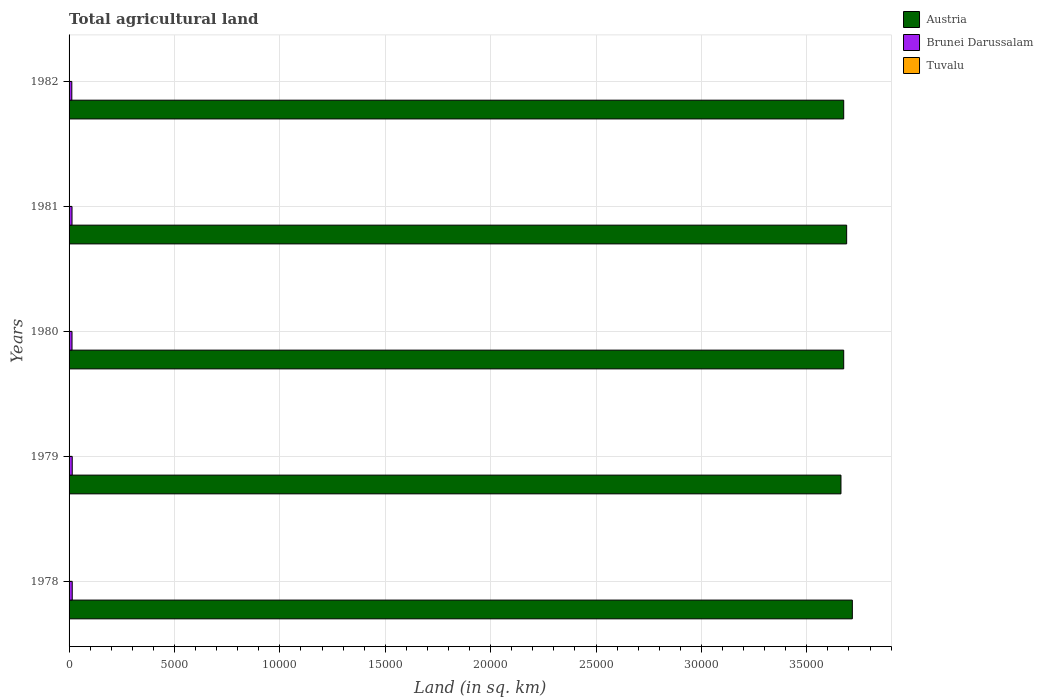How many different coloured bars are there?
Your answer should be very brief. 3. How many groups of bars are there?
Give a very brief answer. 5. Are the number of bars per tick equal to the number of legend labels?
Offer a terse response. Yes. Are the number of bars on each tick of the Y-axis equal?
Provide a short and direct response. Yes. How many bars are there on the 2nd tick from the top?
Make the answer very short. 3. What is the label of the 1st group of bars from the top?
Provide a short and direct response. 1982. What is the total agricultural land in Austria in 1978?
Your answer should be compact. 3.72e+04. Across all years, what is the maximum total agricultural land in Tuvalu?
Offer a terse response. 20. Across all years, what is the minimum total agricultural land in Tuvalu?
Offer a terse response. 20. In which year was the total agricultural land in Tuvalu maximum?
Ensure brevity in your answer.  1978. In which year was the total agricultural land in Brunei Darussalam minimum?
Provide a succinct answer. 1982. What is the total total agricultural land in Austria in the graph?
Ensure brevity in your answer.  1.84e+05. What is the difference between the total agricultural land in Tuvalu in 1981 and that in 1982?
Offer a very short reply. 0. What is the difference between the total agricultural land in Tuvalu in 1981 and the total agricultural land in Austria in 1978?
Offer a terse response. -3.71e+04. What is the average total agricultural land in Brunei Darussalam per year?
Keep it short and to the point. 142. In the year 1978, what is the difference between the total agricultural land in Brunei Darussalam and total agricultural land in Tuvalu?
Give a very brief answer. 130. In how many years, is the total agricultural land in Tuvalu greater than 3000 sq.km?
Offer a terse response. 0. What is the difference between the highest and the second highest total agricultural land in Brunei Darussalam?
Your answer should be compact. 0. What is the difference between the highest and the lowest total agricultural land in Austria?
Offer a terse response. 540. Is the sum of the total agricultural land in Brunei Darussalam in 1980 and 1981 greater than the maximum total agricultural land in Austria across all years?
Provide a short and direct response. No. What does the 1st bar from the top in 1981 represents?
Ensure brevity in your answer.  Tuvalu. What does the 2nd bar from the bottom in 1978 represents?
Your answer should be very brief. Brunei Darussalam. Are all the bars in the graph horizontal?
Provide a short and direct response. Yes. Are the values on the major ticks of X-axis written in scientific E-notation?
Give a very brief answer. No. Does the graph contain grids?
Offer a very short reply. Yes. Where does the legend appear in the graph?
Your answer should be compact. Top right. How many legend labels are there?
Your answer should be very brief. 3. How are the legend labels stacked?
Offer a very short reply. Vertical. What is the title of the graph?
Make the answer very short. Total agricultural land. What is the label or title of the X-axis?
Your response must be concise. Land (in sq. km). What is the Land (in sq. km) in Austria in 1978?
Ensure brevity in your answer.  3.72e+04. What is the Land (in sq. km) of Brunei Darussalam in 1978?
Offer a very short reply. 150. What is the Land (in sq. km) of Austria in 1979?
Provide a short and direct response. 3.66e+04. What is the Land (in sq. km) of Brunei Darussalam in 1979?
Your response must be concise. 150. What is the Land (in sq. km) in Tuvalu in 1979?
Your answer should be compact. 20. What is the Land (in sq. km) of Austria in 1980?
Your answer should be compact. 3.68e+04. What is the Land (in sq. km) in Brunei Darussalam in 1980?
Provide a short and direct response. 140. What is the Land (in sq. km) in Tuvalu in 1980?
Make the answer very short. 20. What is the Land (in sq. km) of Austria in 1981?
Keep it short and to the point. 3.69e+04. What is the Land (in sq. km) in Brunei Darussalam in 1981?
Provide a short and direct response. 140. What is the Land (in sq. km) of Austria in 1982?
Provide a succinct answer. 3.68e+04. What is the Land (in sq. km) in Brunei Darussalam in 1982?
Your response must be concise. 130. Across all years, what is the maximum Land (in sq. km) in Austria?
Make the answer very short. 3.72e+04. Across all years, what is the maximum Land (in sq. km) in Brunei Darussalam?
Provide a succinct answer. 150. Across all years, what is the maximum Land (in sq. km) of Tuvalu?
Provide a succinct answer. 20. Across all years, what is the minimum Land (in sq. km) in Austria?
Your answer should be compact. 3.66e+04. Across all years, what is the minimum Land (in sq. km) in Brunei Darussalam?
Ensure brevity in your answer.  130. What is the total Land (in sq. km) in Austria in the graph?
Your answer should be very brief. 1.84e+05. What is the total Land (in sq. km) in Brunei Darussalam in the graph?
Your response must be concise. 710. What is the difference between the Land (in sq. km) in Austria in 1978 and that in 1979?
Your response must be concise. 540. What is the difference between the Land (in sq. km) of Brunei Darussalam in 1978 and that in 1979?
Your answer should be compact. 0. What is the difference between the Land (in sq. km) in Tuvalu in 1978 and that in 1979?
Keep it short and to the point. 0. What is the difference between the Land (in sq. km) in Austria in 1978 and that in 1980?
Your answer should be compact. 410. What is the difference between the Land (in sq. km) in Austria in 1978 and that in 1981?
Offer a very short reply. 270. What is the difference between the Land (in sq. km) in Tuvalu in 1978 and that in 1981?
Your answer should be compact. 0. What is the difference between the Land (in sq. km) in Austria in 1978 and that in 1982?
Your response must be concise. 410. What is the difference between the Land (in sq. km) of Tuvalu in 1978 and that in 1982?
Offer a terse response. 0. What is the difference between the Land (in sq. km) in Austria in 1979 and that in 1980?
Make the answer very short. -130. What is the difference between the Land (in sq. km) in Brunei Darussalam in 1979 and that in 1980?
Keep it short and to the point. 10. What is the difference between the Land (in sq. km) in Tuvalu in 1979 and that in 1980?
Ensure brevity in your answer.  0. What is the difference between the Land (in sq. km) of Austria in 1979 and that in 1981?
Give a very brief answer. -270. What is the difference between the Land (in sq. km) in Tuvalu in 1979 and that in 1981?
Give a very brief answer. 0. What is the difference between the Land (in sq. km) of Austria in 1979 and that in 1982?
Provide a succinct answer. -130. What is the difference between the Land (in sq. km) of Austria in 1980 and that in 1981?
Offer a very short reply. -140. What is the difference between the Land (in sq. km) in Austria in 1980 and that in 1982?
Keep it short and to the point. 0. What is the difference between the Land (in sq. km) in Brunei Darussalam in 1980 and that in 1982?
Your response must be concise. 10. What is the difference between the Land (in sq. km) of Tuvalu in 1980 and that in 1982?
Make the answer very short. 0. What is the difference between the Land (in sq. km) in Austria in 1981 and that in 1982?
Provide a short and direct response. 140. What is the difference between the Land (in sq. km) in Austria in 1978 and the Land (in sq. km) in Brunei Darussalam in 1979?
Give a very brief answer. 3.70e+04. What is the difference between the Land (in sq. km) of Austria in 1978 and the Land (in sq. km) of Tuvalu in 1979?
Make the answer very short. 3.71e+04. What is the difference between the Land (in sq. km) in Brunei Darussalam in 1978 and the Land (in sq. km) in Tuvalu in 1979?
Your response must be concise. 130. What is the difference between the Land (in sq. km) in Austria in 1978 and the Land (in sq. km) in Brunei Darussalam in 1980?
Give a very brief answer. 3.70e+04. What is the difference between the Land (in sq. km) in Austria in 1978 and the Land (in sq. km) in Tuvalu in 1980?
Offer a very short reply. 3.71e+04. What is the difference between the Land (in sq. km) of Brunei Darussalam in 1978 and the Land (in sq. km) of Tuvalu in 1980?
Offer a very short reply. 130. What is the difference between the Land (in sq. km) of Austria in 1978 and the Land (in sq. km) of Brunei Darussalam in 1981?
Your response must be concise. 3.70e+04. What is the difference between the Land (in sq. km) of Austria in 1978 and the Land (in sq. km) of Tuvalu in 1981?
Your answer should be very brief. 3.71e+04. What is the difference between the Land (in sq. km) of Brunei Darussalam in 1978 and the Land (in sq. km) of Tuvalu in 1981?
Offer a very short reply. 130. What is the difference between the Land (in sq. km) in Austria in 1978 and the Land (in sq. km) in Brunei Darussalam in 1982?
Keep it short and to the point. 3.70e+04. What is the difference between the Land (in sq. km) in Austria in 1978 and the Land (in sq. km) in Tuvalu in 1982?
Provide a succinct answer. 3.71e+04. What is the difference between the Land (in sq. km) in Brunei Darussalam in 1978 and the Land (in sq. km) in Tuvalu in 1982?
Provide a short and direct response. 130. What is the difference between the Land (in sq. km) in Austria in 1979 and the Land (in sq. km) in Brunei Darussalam in 1980?
Your response must be concise. 3.65e+04. What is the difference between the Land (in sq. km) in Austria in 1979 and the Land (in sq. km) in Tuvalu in 1980?
Your response must be concise. 3.66e+04. What is the difference between the Land (in sq. km) of Brunei Darussalam in 1979 and the Land (in sq. km) of Tuvalu in 1980?
Your answer should be compact. 130. What is the difference between the Land (in sq. km) in Austria in 1979 and the Land (in sq. km) in Brunei Darussalam in 1981?
Ensure brevity in your answer.  3.65e+04. What is the difference between the Land (in sq. km) of Austria in 1979 and the Land (in sq. km) of Tuvalu in 1981?
Make the answer very short. 3.66e+04. What is the difference between the Land (in sq. km) of Brunei Darussalam in 1979 and the Land (in sq. km) of Tuvalu in 1981?
Your answer should be very brief. 130. What is the difference between the Land (in sq. km) in Austria in 1979 and the Land (in sq. km) in Brunei Darussalam in 1982?
Give a very brief answer. 3.65e+04. What is the difference between the Land (in sq. km) in Austria in 1979 and the Land (in sq. km) in Tuvalu in 1982?
Offer a very short reply. 3.66e+04. What is the difference between the Land (in sq. km) in Brunei Darussalam in 1979 and the Land (in sq. km) in Tuvalu in 1982?
Provide a succinct answer. 130. What is the difference between the Land (in sq. km) of Austria in 1980 and the Land (in sq. km) of Brunei Darussalam in 1981?
Make the answer very short. 3.66e+04. What is the difference between the Land (in sq. km) in Austria in 1980 and the Land (in sq. km) in Tuvalu in 1981?
Offer a very short reply. 3.67e+04. What is the difference between the Land (in sq. km) of Brunei Darussalam in 1980 and the Land (in sq. km) of Tuvalu in 1981?
Your response must be concise. 120. What is the difference between the Land (in sq. km) in Austria in 1980 and the Land (in sq. km) in Brunei Darussalam in 1982?
Provide a succinct answer. 3.66e+04. What is the difference between the Land (in sq. km) of Austria in 1980 and the Land (in sq. km) of Tuvalu in 1982?
Offer a very short reply. 3.67e+04. What is the difference between the Land (in sq. km) of Brunei Darussalam in 1980 and the Land (in sq. km) of Tuvalu in 1982?
Ensure brevity in your answer.  120. What is the difference between the Land (in sq. km) of Austria in 1981 and the Land (in sq. km) of Brunei Darussalam in 1982?
Offer a very short reply. 3.68e+04. What is the difference between the Land (in sq. km) in Austria in 1981 and the Land (in sq. km) in Tuvalu in 1982?
Provide a short and direct response. 3.69e+04. What is the difference between the Land (in sq. km) of Brunei Darussalam in 1981 and the Land (in sq. km) of Tuvalu in 1982?
Offer a terse response. 120. What is the average Land (in sq. km) of Austria per year?
Provide a short and direct response. 3.68e+04. What is the average Land (in sq. km) in Brunei Darussalam per year?
Ensure brevity in your answer.  142. In the year 1978, what is the difference between the Land (in sq. km) in Austria and Land (in sq. km) in Brunei Darussalam?
Keep it short and to the point. 3.70e+04. In the year 1978, what is the difference between the Land (in sq. km) of Austria and Land (in sq. km) of Tuvalu?
Your answer should be very brief. 3.71e+04. In the year 1978, what is the difference between the Land (in sq. km) of Brunei Darussalam and Land (in sq. km) of Tuvalu?
Ensure brevity in your answer.  130. In the year 1979, what is the difference between the Land (in sq. km) in Austria and Land (in sq. km) in Brunei Darussalam?
Give a very brief answer. 3.65e+04. In the year 1979, what is the difference between the Land (in sq. km) in Austria and Land (in sq. km) in Tuvalu?
Offer a very short reply. 3.66e+04. In the year 1979, what is the difference between the Land (in sq. km) in Brunei Darussalam and Land (in sq. km) in Tuvalu?
Offer a terse response. 130. In the year 1980, what is the difference between the Land (in sq. km) of Austria and Land (in sq. km) of Brunei Darussalam?
Your answer should be very brief. 3.66e+04. In the year 1980, what is the difference between the Land (in sq. km) in Austria and Land (in sq. km) in Tuvalu?
Provide a succinct answer. 3.67e+04. In the year 1980, what is the difference between the Land (in sq. km) in Brunei Darussalam and Land (in sq. km) in Tuvalu?
Make the answer very short. 120. In the year 1981, what is the difference between the Land (in sq. km) of Austria and Land (in sq. km) of Brunei Darussalam?
Give a very brief answer. 3.68e+04. In the year 1981, what is the difference between the Land (in sq. km) of Austria and Land (in sq. km) of Tuvalu?
Give a very brief answer. 3.69e+04. In the year 1981, what is the difference between the Land (in sq. km) in Brunei Darussalam and Land (in sq. km) in Tuvalu?
Give a very brief answer. 120. In the year 1982, what is the difference between the Land (in sq. km) of Austria and Land (in sq. km) of Brunei Darussalam?
Your answer should be compact. 3.66e+04. In the year 1982, what is the difference between the Land (in sq. km) in Austria and Land (in sq. km) in Tuvalu?
Make the answer very short. 3.67e+04. In the year 1982, what is the difference between the Land (in sq. km) of Brunei Darussalam and Land (in sq. km) of Tuvalu?
Provide a short and direct response. 110. What is the ratio of the Land (in sq. km) in Austria in 1978 to that in 1979?
Keep it short and to the point. 1.01. What is the ratio of the Land (in sq. km) of Tuvalu in 1978 to that in 1979?
Offer a very short reply. 1. What is the ratio of the Land (in sq. km) of Austria in 1978 to that in 1980?
Give a very brief answer. 1.01. What is the ratio of the Land (in sq. km) of Brunei Darussalam in 1978 to that in 1980?
Offer a terse response. 1.07. What is the ratio of the Land (in sq. km) in Austria in 1978 to that in 1981?
Keep it short and to the point. 1.01. What is the ratio of the Land (in sq. km) of Brunei Darussalam in 1978 to that in 1981?
Your answer should be very brief. 1.07. What is the ratio of the Land (in sq. km) of Austria in 1978 to that in 1982?
Offer a very short reply. 1.01. What is the ratio of the Land (in sq. km) of Brunei Darussalam in 1978 to that in 1982?
Give a very brief answer. 1.15. What is the ratio of the Land (in sq. km) in Tuvalu in 1978 to that in 1982?
Your response must be concise. 1. What is the ratio of the Land (in sq. km) in Brunei Darussalam in 1979 to that in 1980?
Your answer should be very brief. 1.07. What is the ratio of the Land (in sq. km) in Tuvalu in 1979 to that in 1980?
Offer a terse response. 1. What is the ratio of the Land (in sq. km) in Austria in 1979 to that in 1981?
Offer a terse response. 0.99. What is the ratio of the Land (in sq. km) in Brunei Darussalam in 1979 to that in 1981?
Give a very brief answer. 1.07. What is the ratio of the Land (in sq. km) in Austria in 1979 to that in 1982?
Offer a terse response. 1. What is the ratio of the Land (in sq. km) of Brunei Darussalam in 1979 to that in 1982?
Provide a succinct answer. 1.15. What is the ratio of the Land (in sq. km) in Brunei Darussalam in 1980 to that in 1981?
Keep it short and to the point. 1. What is the ratio of the Land (in sq. km) of Tuvalu in 1980 to that in 1981?
Keep it short and to the point. 1. What is the ratio of the Land (in sq. km) of Austria in 1980 to that in 1982?
Give a very brief answer. 1. What is the ratio of the Land (in sq. km) in Tuvalu in 1980 to that in 1982?
Keep it short and to the point. 1. What is the ratio of the Land (in sq. km) of Austria in 1981 to that in 1982?
Make the answer very short. 1. What is the ratio of the Land (in sq. km) of Brunei Darussalam in 1981 to that in 1982?
Your answer should be very brief. 1.08. What is the difference between the highest and the second highest Land (in sq. km) of Austria?
Provide a short and direct response. 270. What is the difference between the highest and the second highest Land (in sq. km) in Tuvalu?
Ensure brevity in your answer.  0. What is the difference between the highest and the lowest Land (in sq. km) of Austria?
Your answer should be very brief. 540. What is the difference between the highest and the lowest Land (in sq. km) in Brunei Darussalam?
Offer a very short reply. 20. 